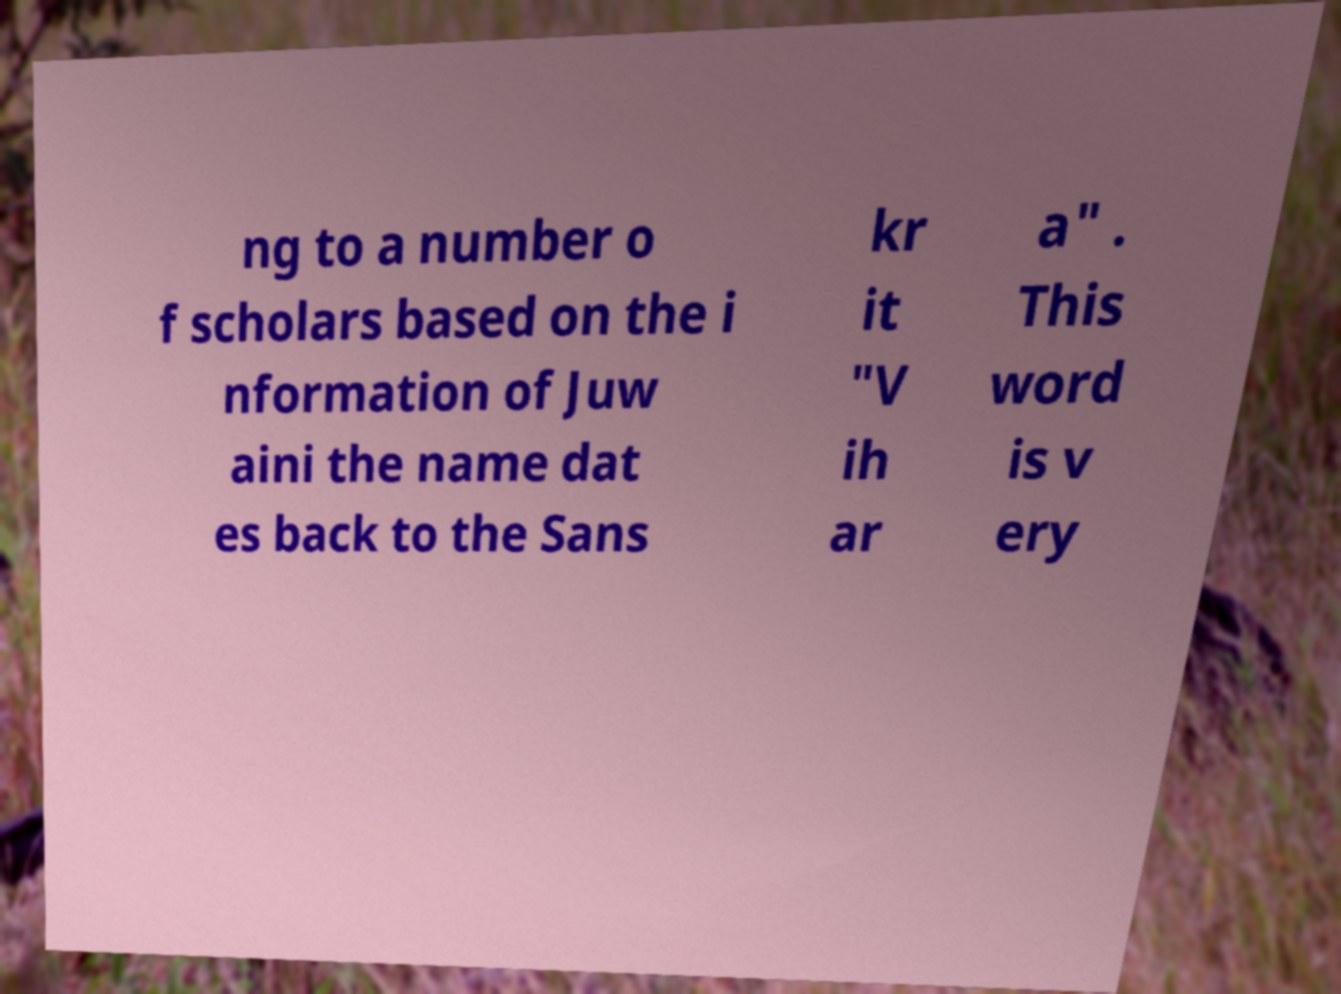Please identify and transcribe the text found in this image. ng to a number o f scholars based on the i nformation of Juw aini the name dat es back to the Sans kr it "V ih ar a" . This word is v ery 